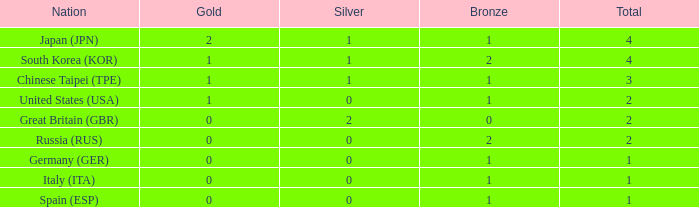What is the rank of the country with more than 2 medals, and 2 gold medals? 1.0. 